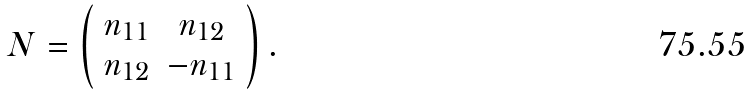Convert formula to latex. <formula><loc_0><loc_0><loc_500><loc_500>N = \left ( \begin{array} { c c c } n _ { 1 1 } & n _ { 1 2 } \\ n _ { 1 2 } & - n _ { 1 1 } \end{array} \right ) .</formula> 